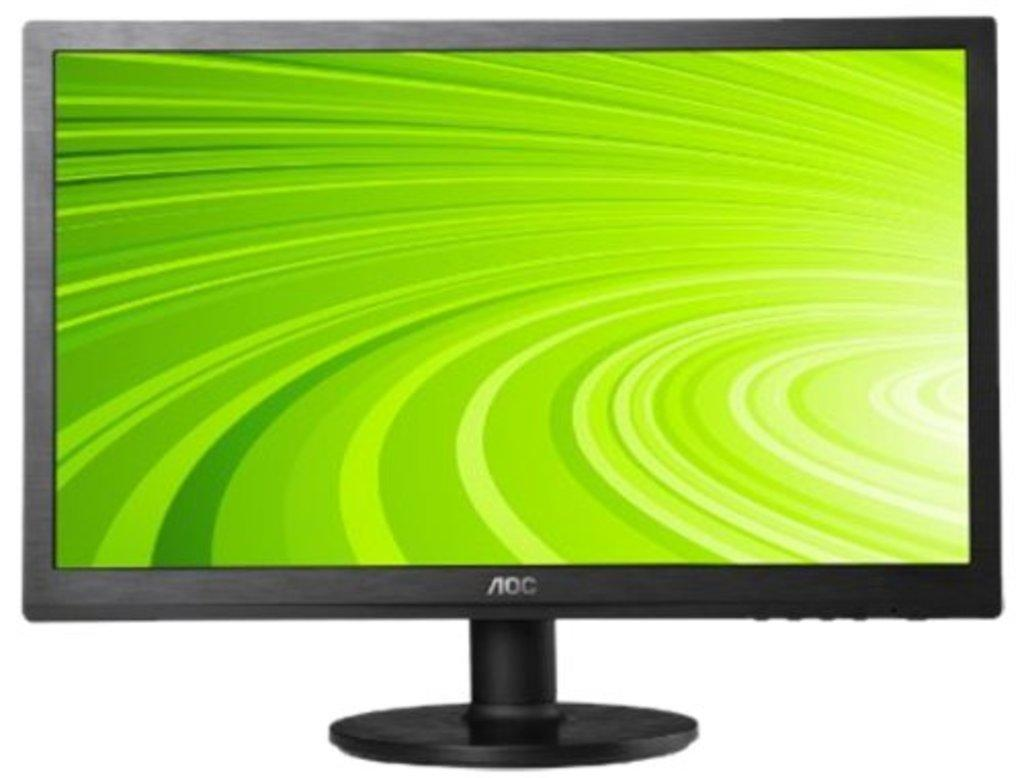<image>
Relay a brief, clear account of the picture shown. A product like shot of an AOC TV. It has a green screensaver. 